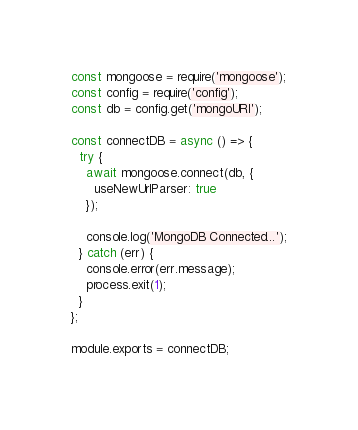<code> <loc_0><loc_0><loc_500><loc_500><_JavaScript_>const mongoose = require('mongoose');
const config = require('config');
const db = config.get('mongoURI');

const connectDB = async () => {
  try {
    await mongoose.connect(db, {
      useNewUrlParser: true
    });

    console.log('MongoDB Connected...');
  } catch (err) {
    console.error(err.message);
    process.exit(1);
  }
};

module.exports = connectDB;</code> 